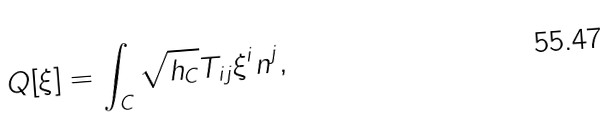<formula> <loc_0><loc_0><loc_500><loc_500>Q [ \xi ] = \int _ { C } \sqrt { h _ { C } } T _ { i j } \xi ^ { i } n ^ { j } ,</formula> 